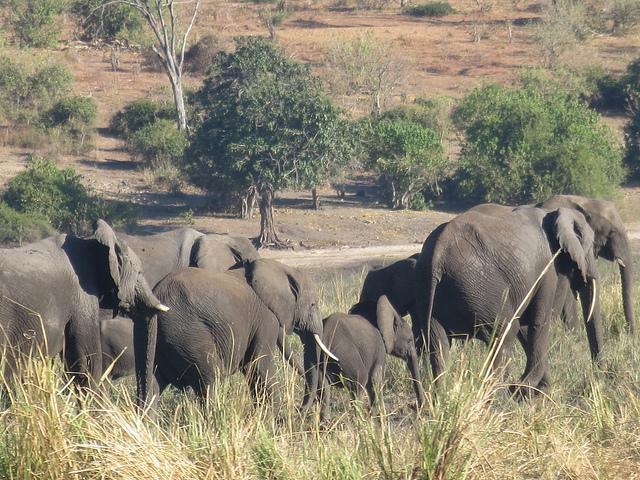How many babies in the picture?
Give a very brief answer. 1. How many elephants can be seen?
Give a very brief answer. 6. How many elephants are in the picture?
Give a very brief answer. 7. How many zebras are shown?
Give a very brief answer. 0. 